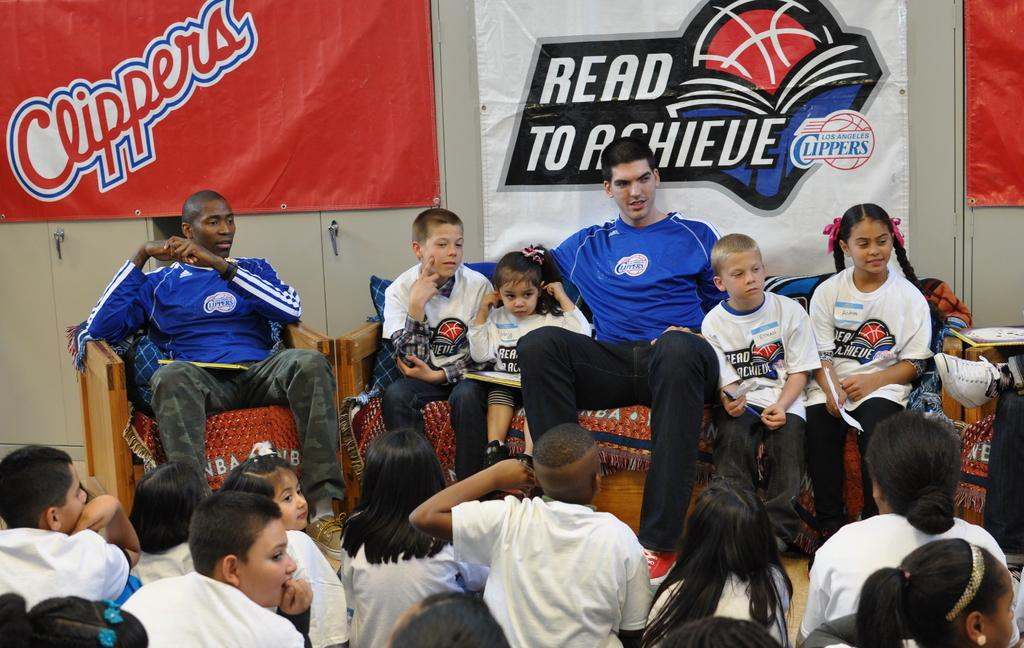<image>
Offer a succinct explanation of the picture presented. Several people in front of a banner that says Read to achieve. 